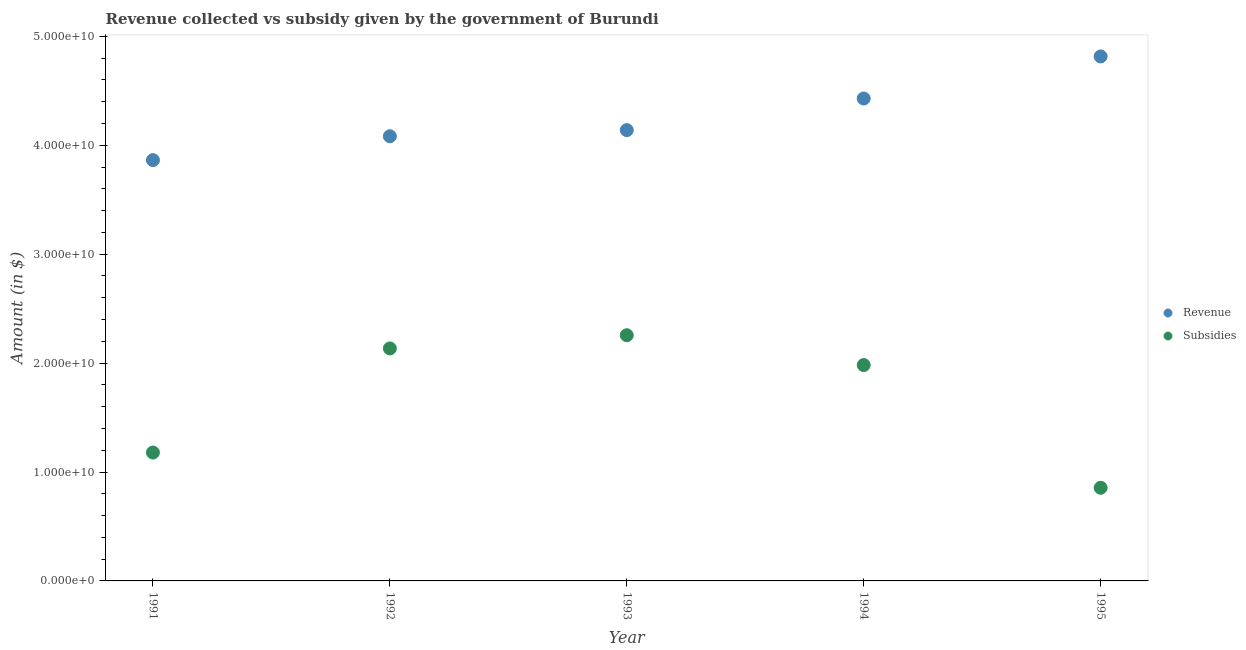How many different coloured dotlines are there?
Provide a succinct answer. 2. Is the number of dotlines equal to the number of legend labels?
Offer a terse response. Yes. What is the amount of subsidies given in 1995?
Provide a succinct answer. 8.55e+09. Across all years, what is the maximum amount of revenue collected?
Your answer should be very brief. 4.82e+1. Across all years, what is the minimum amount of revenue collected?
Give a very brief answer. 3.86e+1. In which year was the amount of revenue collected minimum?
Keep it short and to the point. 1991. What is the total amount of subsidies given in the graph?
Provide a succinct answer. 8.41e+1. What is the difference between the amount of revenue collected in 1994 and that in 1995?
Your response must be concise. -3.86e+09. What is the difference between the amount of subsidies given in 1993 and the amount of revenue collected in 1992?
Keep it short and to the point. -1.83e+1. What is the average amount of subsidies given per year?
Offer a terse response. 1.68e+1. In the year 1994, what is the difference between the amount of revenue collected and amount of subsidies given?
Your answer should be compact. 2.45e+1. In how many years, is the amount of subsidies given greater than 20000000000 $?
Give a very brief answer. 2. What is the ratio of the amount of revenue collected in 1993 to that in 1995?
Your response must be concise. 0.86. Is the amount of revenue collected in 1992 less than that in 1994?
Your answer should be very brief. Yes. Is the difference between the amount of subsidies given in 1991 and 1993 greater than the difference between the amount of revenue collected in 1991 and 1993?
Make the answer very short. No. What is the difference between the highest and the second highest amount of subsidies given?
Your answer should be compact. 1.21e+09. What is the difference between the highest and the lowest amount of revenue collected?
Provide a succinct answer. 9.52e+09. In how many years, is the amount of revenue collected greater than the average amount of revenue collected taken over all years?
Provide a short and direct response. 2. Is the sum of the amount of revenue collected in 1992 and 1994 greater than the maximum amount of subsidies given across all years?
Your answer should be very brief. Yes. Does the amount of revenue collected monotonically increase over the years?
Offer a terse response. Yes. How many dotlines are there?
Offer a very short reply. 2. Are the values on the major ticks of Y-axis written in scientific E-notation?
Make the answer very short. Yes. Does the graph contain any zero values?
Ensure brevity in your answer.  No. Where does the legend appear in the graph?
Provide a succinct answer. Center right. What is the title of the graph?
Your response must be concise. Revenue collected vs subsidy given by the government of Burundi. Does "Current education expenditure" appear as one of the legend labels in the graph?
Give a very brief answer. No. What is the label or title of the X-axis?
Offer a very short reply. Year. What is the label or title of the Y-axis?
Make the answer very short. Amount (in $). What is the Amount (in $) in Revenue in 1991?
Make the answer very short. 3.86e+1. What is the Amount (in $) of Subsidies in 1991?
Offer a terse response. 1.18e+1. What is the Amount (in $) in Revenue in 1992?
Your answer should be very brief. 4.08e+1. What is the Amount (in $) of Subsidies in 1992?
Provide a short and direct response. 2.13e+1. What is the Amount (in $) in Revenue in 1993?
Provide a short and direct response. 4.14e+1. What is the Amount (in $) of Subsidies in 1993?
Offer a terse response. 2.26e+1. What is the Amount (in $) in Revenue in 1994?
Your response must be concise. 4.43e+1. What is the Amount (in $) of Subsidies in 1994?
Your answer should be compact. 1.98e+1. What is the Amount (in $) of Revenue in 1995?
Provide a succinct answer. 4.82e+1. What is the Amount (in $) in Subsidies in 1995?
Keep it short and to the point. 8.55e+09. Across all years, what is the maximum Amount (in $) of Revenue?
Give a very brief answer. 4.82e+1. Across all years, what is the maximum Amount (in $) of Subsidies?
Ensure brevity in your answer.  2.26e+1. Across all years, what is the minimum Amount (in $) in Revenue?
Your response must be concise. 3.86e+1. Across all years, what is the minimum Amount (in $) of Subsidies?
Make the answer very short. 8.55e+09. What is the total Amount (in $) in Revenue in the graph?
Offer a very short reply. 2.13e+11. What is the total Amount (in $) of Subsidies in the graph?
Provide a succinct answer. 8.41e+1. What is the difference between the Amount (in $) of Revenue in 1991 and that in 1992?
Make the answer very short. -2.19e+09. What is the difference between the Amount (in $) of Subsidies in 1991 and that in 1992?
Your answer should be compact. -9.56e+09. What is the difference between the Amount (in $) of Revenue in 1991 and that in 1993?
Your response must be concise. -2.76e+09. What is the difference between the Amount (in $) of Subsidies in 1991 and that in 1993?
Your answer should be compact. -1.08e+1. What is the difference between the Amount (in $) in Revenue in 1991 and that in 1994?
Provide a succinct answer. -5.66e+09. What is the difference between the Amount (in $) in Subsidies in 1991 and that in 1994?
Offer a terse response. -8.04e+09. What is the difference between the Amount (in $) in Revenue in 1991 and that in 1995?
Your response must be concise. -9.52e+09. What is the difference between the Amount (in $) in Subsidies in 1991 and that in 1995?
Make the answer very short. 3.24e+09. What is the difference between the Amount (in $) in Revenue in 1992 and that in 1993?
Provide a succinct answer. -5.64e+08. What is the difference between the Amount (in $) in Subsidies in 1992 and that in 1993?
Your answer should be very brief. -1.21e+09. What is the difference between the Amount (in $) of Revenue in 1992 and that in 1994?
Give a very brief answer. -3.47e+09. What is the difference between the Amount (in $) in Subsidies in 1992 and that in 1994?
Provide a short and direct response. 1.53e+09. What is the difference between the Amount (in $) of Revenue in 1992 and that in 1995?
Your answer should be compact. -7.33e+09. What is the difference between the Amount (in $) of Subsidies in 1992 and that in 1995?
Provide a short and direct response. 1.28e+1. What is the difference between the Amount (in $) in Revenue in 1993 and that in 1994?
Give a very brief answer. -2.90e+09. What is the difference between the Amount (in $) in Subsidies in 1993 and that in 1994?
Keep it short and to the point. 2.74e+09. What is the difference between the Amount (in $) of Revenue in 1993 and that in 1995?
Offer a terse response. -6.76e+09. What is the difference between the Amount (in $) in Subsidies in 1993 and that in 1995?
Your answer should be compact. 1.40e+1. What is the difference between the Amount (in $) of Revenue in 1994 and that in 1995?
Your answer should be compact. -3.86e+09. What is the difference between the Amount (in $) of Subsidies in 1994 and that in 1995?
Keep it short and to the point. 1.13e+1. What is the difference between the Amount (in $) in Revenue in 1991 and the Amount (in $) in Subsidies in 1992?
Provide a short and direct response. 1.73e+1. What is the difference between the Amount (in $) in Revenue in 1991 and the Amount (in $) in Subsidies in 1993?
Your response must be concise. 1.61e+1. What is the difference between the Amount (in $) in Revenue in 1991 and the Amount (in $) in Subsidies in 1994?
Offer a terse response. 1.88e+1. What is the difference between the Amount (in $) in Revenue in 1991 and the Amount (in $) in Subsidies in 1995?
Make the answer very short. 3.01e+1. What is the difference between the Amount (in $) of Revenue in 1992 and the Amount (in $) of Subsidies in 1993?
Offer a very short reply. 1.83e+1. What is the difference between the Amount (in $) in Revenue in 1992 and the Amount (in $) in Subsidies in 1994?
Your answer should be compact. 2.10e+1. What is the difference between the Amount (in $) of Revenue in 1992 and the Amount (in $) of Subsidies in 1995?
Make the answer very short. 3.23e+1. What is the difference between the Amount (in $) of Revenue in 1993 and the Amount (in $) of Subsidies in 1994?
Your answer should be compact. 2.16e+1. What is the difference between the Amount (in $) of Revenue in 1993 and the Amount (in $) of Subsidies in 1995?
Offer a very short reply. 3.28e+1. What is the difference between the Amount (in $) in Revenue in 1994 and the Amount (in $) in Subsidies in 1995?
Keep it short and to the point. 3.57e+1. What is the average Amount (in $) in Revenue per year?
Provide a short and direct response. 4.27e+1. What is the average Amount (in $) in Subsidies per year?
Offer a very short reply. 1.68e+1. In the year 1991, what is the difference between the Amount (in $) of Revenue and Amount (in $) of Subsidies?
Make the answer very short. 2.69e+1. In the year 1992, what is the difference between the Amount (in $) of Revenue and Amount (in $) of Subsidies?
Your response must be concise. 1.95e+1. In the year 1993, what is the difference between the Amount (in $) of Revenue and Amount (in $) of Subsidies?
Your answer should be very brief. 1.88e+1. In the year 1994, what is the difference between the Amount (in $) of Revenue and Amount (in $) of Subsidies?
Provide a succinct answer. 2.45e+1. In the year 1995, what is the difference between the Amount (in $) in Revenue and Amount (in $) in Subsidies?
Offer a terse response. 3.96e+1. What is the ratio of the Amount (in $) of Revenue in 1991 to that in 1992?
Provide a short and direct response. 0.95. What is the ratio of the Amount (in $) in Subsidies in 1991 to that in 1992?
Your answer should be very brief. 0.55. What is the ratio of the Amount (in $) in Revenue in 1991 to that in 1993?
Provide a succinct answer. 0.93. What is the ratio of the Amount (in $) of Subsidies in 1991 to that in 1993?
Your answer should be very brief. 0.52. What is the ratio of the Amount (in $) in Revenue in 1991 to that in 1994?
Give a very brief answer. 0.87. What is the ratio of the Amount (in $) in Subsidies in 1991 to that in 1994?
Offer a very short reply. 0.59. What is the ratio of the Amount (in $) of Revenue in 1991 to that in 1995?
Provide a short and direct response. 0.8. What is the ratio of the Amount (in $) in Subsidies in 1991 to that in 1995?
Ensure brevity in your answer.  1.38. What is the ratio of the Amount (in $) of Revenue in 1992 to that in 1993?
Your answer should be compact. 0.99. What is the ratio of the Amount (in $) in Subsidies in 1992 to that in 1993?
Make the answer very short. 0.95. What is the ratio of the Amount (in $) of Revenue in 1992 to that in 1994?
Your answer should be very brief. 0.92. What is the ratio of the Amount (in $) of Subsidies in 1992 to that in 1994?
Provide a short and direct response. 1.08. What is the ratio of the Amount (in $) of Revenue in 1992 to that in 1995?
Ensure brevity in your answer.  0.85. What is the ratio of the Amount (in $) in Subsidies in 1992 to that in 1995?
Keep it short and to the point. 2.5. What is the ratio of the Amount (in $) in Revenue in 1993 to that in 1994?
Your answer should be very brief. 0.93. What is the ratio of the Amount (in $) in Subsidies in 1993 to that in 1994?
Offer a terse response. 1.14. What is the ratio of the Amount (in $) of Revenue in 1993 to that in 1995?
Your answer should be very brief. 0.86. What is the ratio of the Amount (in $) in Subsidies in 1993 to that in 1995?
Ensure brevity in your answer.  2.64. What is the ratio of the Amount (in $) of Revenue in 1994 to that in 1995?
Offer a very short reply. 0.92. What is the ratio of the Amount (in $) in Subsidies in 1994 to that in 1995?
Provide a short and direct response. 2.32. What is the difference between the highest and the second highest Amount (in $) in Revenue?
Provide a succinct answer. 3.86e+09. What is the difference between the highest and the second highest Amount (in $) of Subsidies?
Offer a terse response. 1.21e+09. What is the difference between the highest and the lowest Amount (in $) in Revenue?
Your answer should be very brief. 9.52e+09. What is the difference between the highest and the lowest Amount (in $) in Subsidies?
Your answer should be very brief. 1.40e+1. 